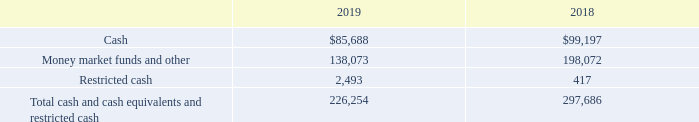Cash and Cash Equivalents and Restricted Cash: Cash equivalents include short-term highly liquid investments and are classified as Level 1 in the fair value hierarchy described below. Restricted cash represents cash received from customers to settle invoices sold under accounts receivable purchase agreements that is contractually required to be set aside. The restrictions will lapse when the cash is remitted to the purchaser of the receivables. Restricted cash is also classified as Level 1 in the fair value hierarchy described below.
As of September 28, 2019 and September 29, 2018, cash and cash equivalents and restricted cash consisted of the following (in thousands):
Which years does the table provide information for cash and cash equivalents and restricted cash? 2019, 2018. What was the amount of Cash in 2018?
Answer scale should be: thousand. 99,197. What was the amount of Restricted Cash in 2019?
Answer scale should be: thousand. 2,493. How many years did the Money market funds and other exceed $100,000 thousand? 2019##2018
Answer: 2. What was the change in the Restricted cash between 2018 and 2019? 2,493-417
Answer: 2076. What was the percentage change in the Total cash and cash equivalents and restricted cash between 2018 and 2019?
Answer scale should be: percent. (226,254-297,686)/297,686
Answer: -24. 